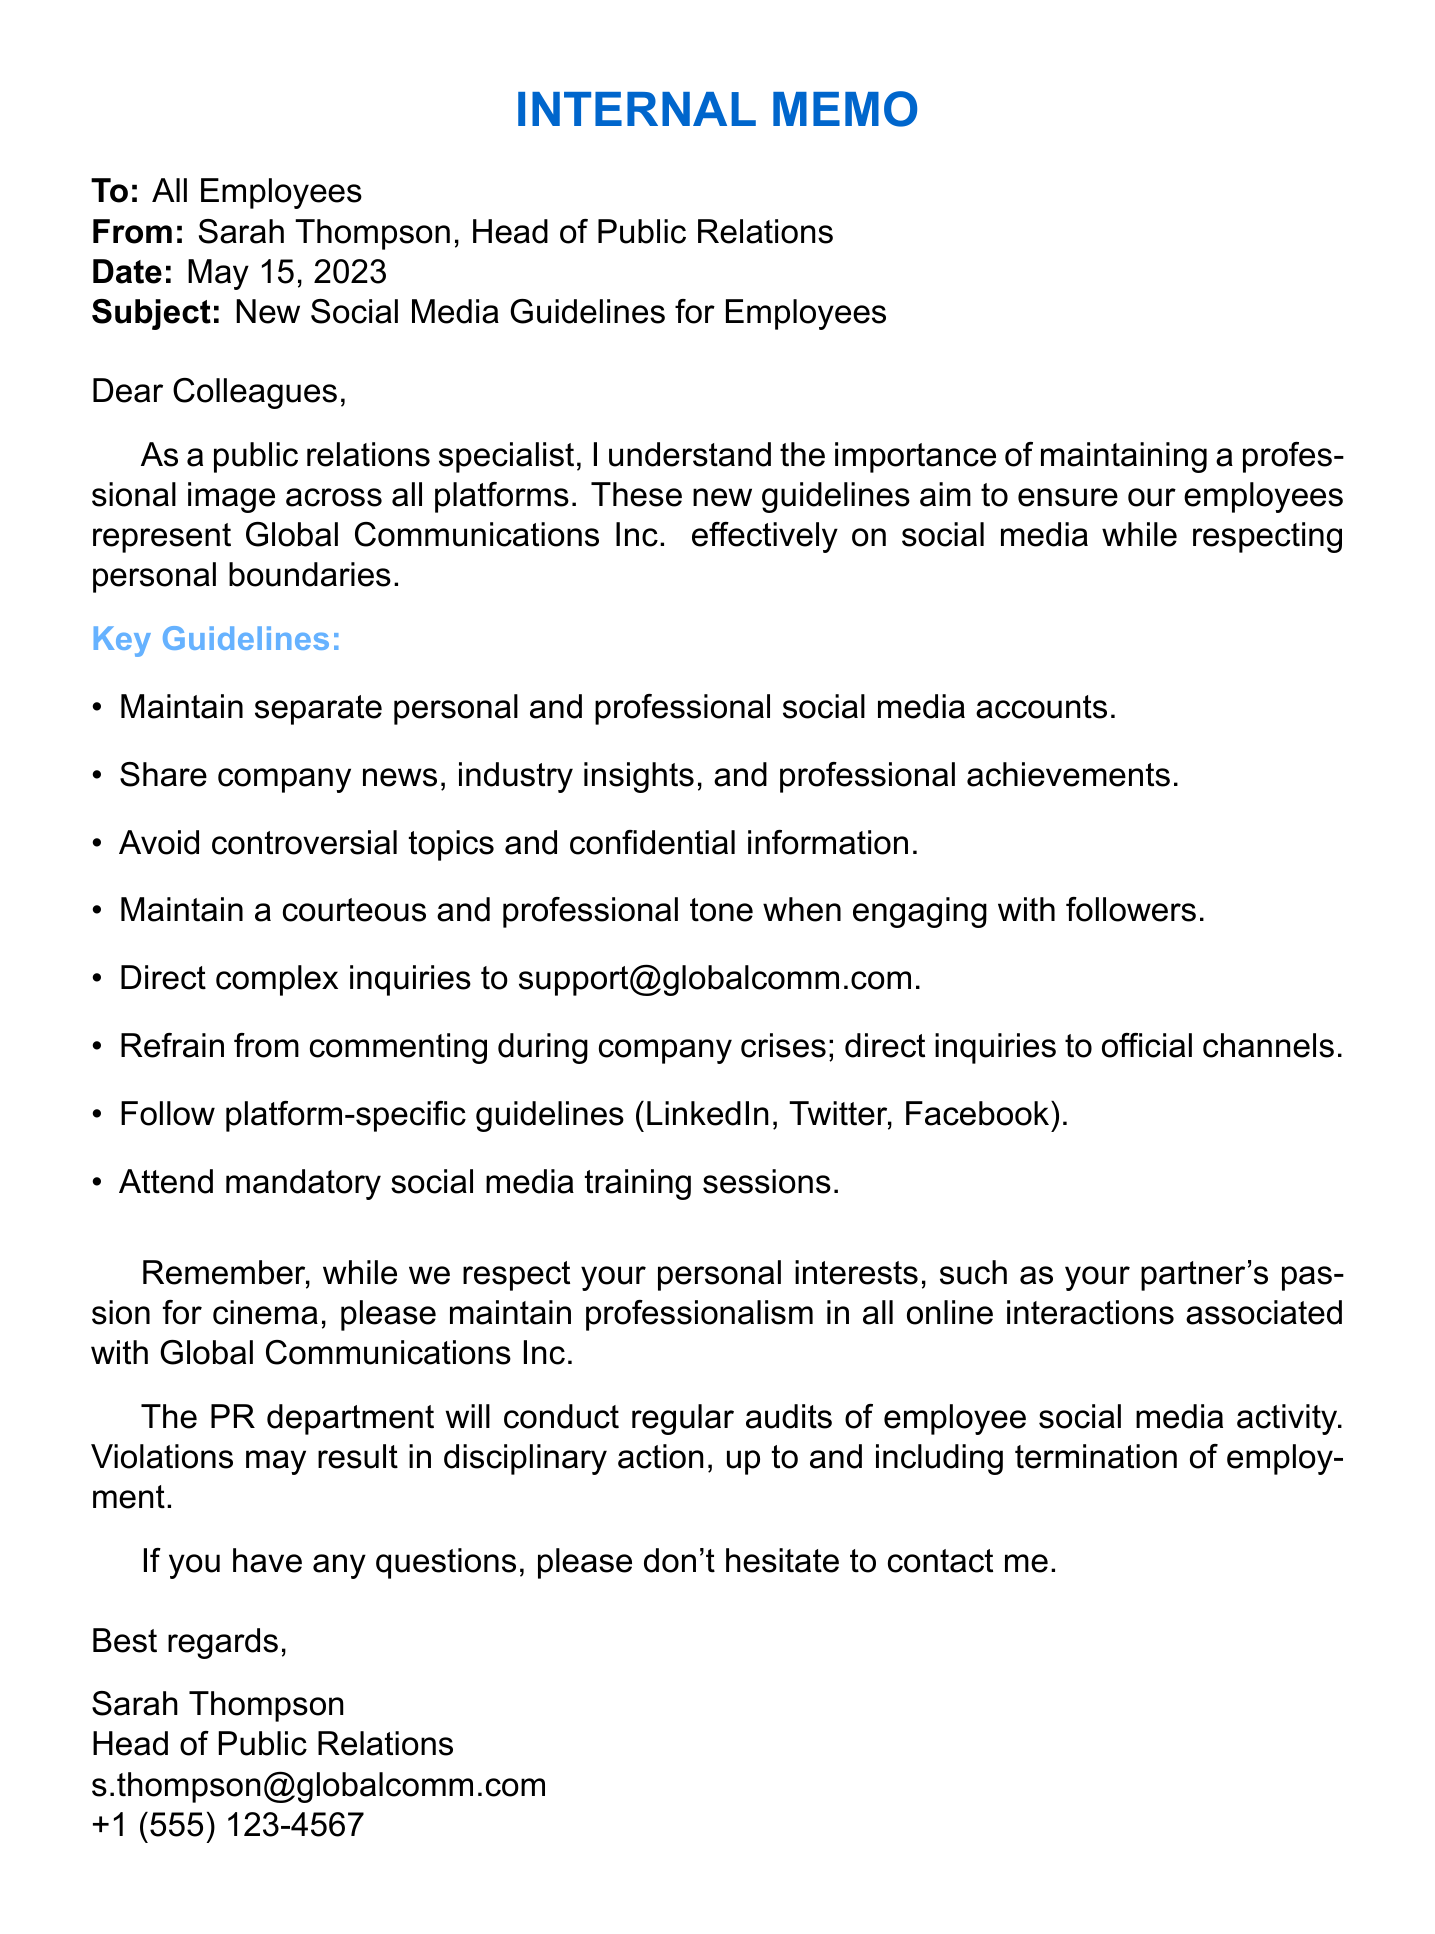What is the name of the sender? The name of the sender is listed at the beginning of the memo as Sarah Thompson.
Answer: Sarah Thompson What is the date of the memo? The date of the memo is explicitly mentioned at the top of the document.
Answer: May 15, 2023 What should employees do when encountering a company crisis on social media? The memo states that employees should refrain from commenting during a company crisis and direct inquiries to official channels.
Answer: Refrain from commenting What is the email address for complex inquiries? The memo provides a specific email address for employees to direct complex inquiries or complaints.
Answer: support@globalcomm.com Who is conducting the social media training sessions? The memo specifies that social media training sessions will be conducted by an industry expert.
Answer: Rachel Chen How many topics should employees avoid posting about? The section on Acceptable Content mentions multiple controversial topics to avoid; the total number mentioned is four.
Answer: Four What will happen if employees violate the social media guidelines? The document states the consequences of violating the guidelines, which can lead to disciplinary action.
Answer: Disciplinary action What type of social media accounts should employees maintain? The guidelines recommend that employees maintain separate accounts for different purposes.
Answer: Separate personal and professional accounts What is the focus for LinkedIn use, according to the guidelines? The memo outlines specific guidelines for content type on LinkedIn, indicating its purpose.
Answer: Professional content and networking 